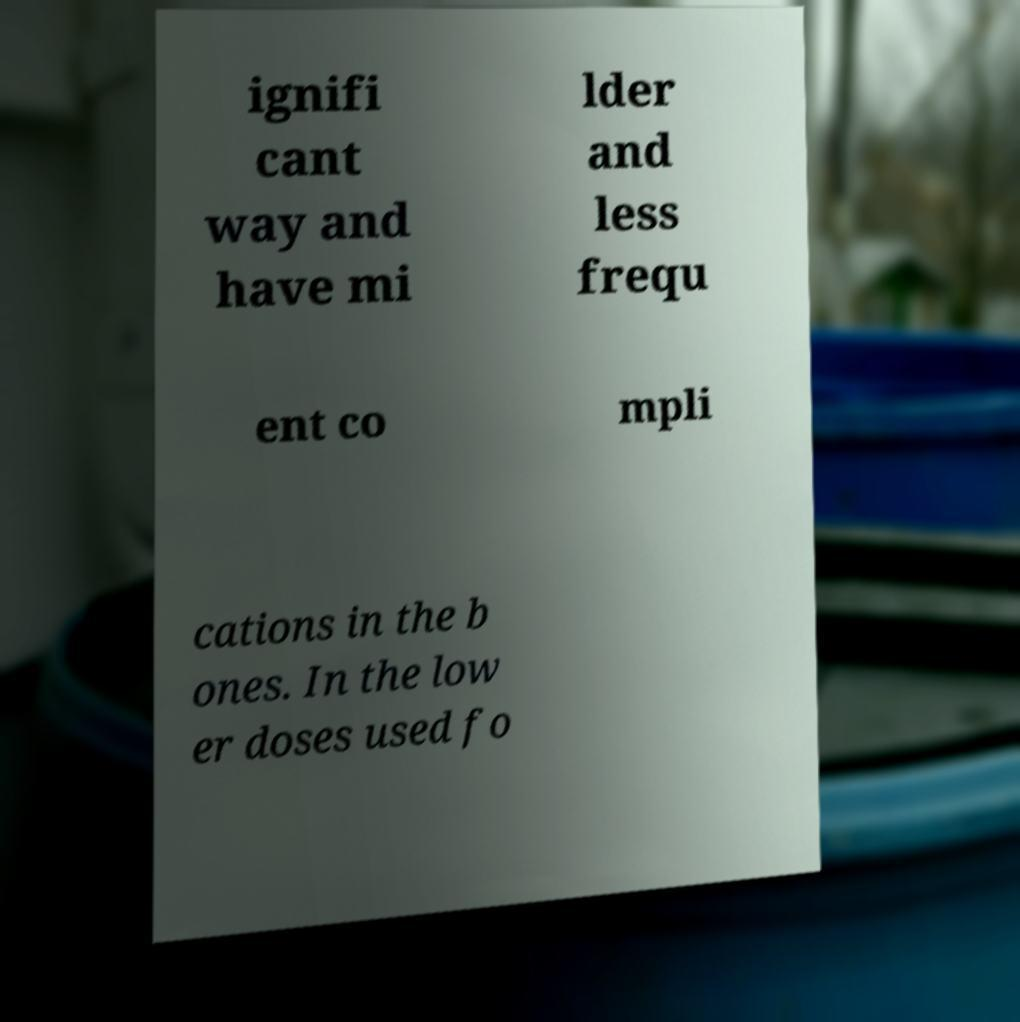I need the written content from this picture converted into text. Can you do that? ignifi cant way and have mi lder and less frequ ent co mpli cations in the b ones. In the low er doses used fo 